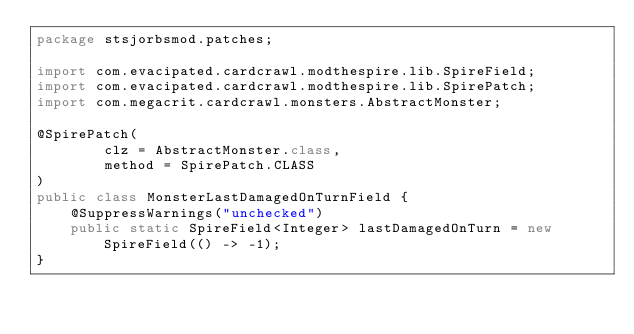Convert code to text. <code><loc_0><loc_0><loc_500><loc_500><_Java_>package stsjorbsmod.patches;

import com.evacipated.cardcrawl.modthespire.lib.SpireField;
import com.evacipated.cardcrawl.modthespire.lib.SpirePatch;
import com.megacrit.cardcrawl.monsters.AbstractMonster;

@SpirePatch(
        clz = AbstractMonster.class,
        method = SpirePatch.CLASS
)
public class MonsterLastDamagedOnTurnField {
    @SuppressWarnings("unchecked")
    public static SpireField<Integer> lastDamagedOnTurn = new SpireField(() -> -1);
}</code> 